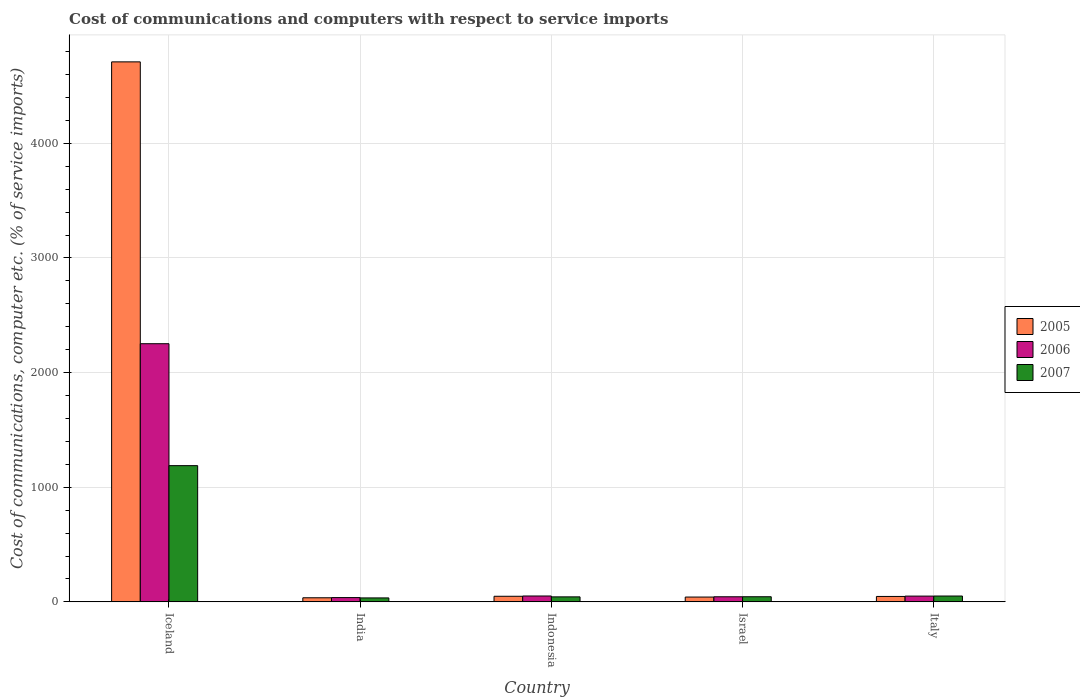How many groups of bars are there?
Your answer should be compact. 5. Are the number of bars on each tick of the X-axis equal?
Ensure brevity in your answer.  Yes. In how many cases, is the number of bars for a given country not equal to the number of legend labels?
Your answer should be compact. 0. What is the cost of communications and computers in 2007 in Iceland?
Offer a terse response. 1188.27. Across all countries, what is the maximum cost of communications and computers in 2005?
Your response must be concise. 4710.44. Across all countries, what is the minimum cost of communications and computers in 2007?
Make the answer very short. 34.57. In which country was the cost of communications and computers in 2007 maximum?
Keep it short and to the point. Iceland. In which country was the cost of communications and computers in 2006 minimum?
Keep it short and to the point. India. What is the total cost of communications and computers in 2006 in the graph?
Offer a very short reply. 2435.6. What is the difference between the cost of communications and computers in 2007 in India and that in Italy?
Give a very brief answer. -16.51. What is the difference between the cost of communications and computers in 2005 in Israel and the cost of communications and computers in 2006 in Indonesia?
Give a very brief answer. -9.27. What is the average cost of communications and computers in 2007 per country?
Ensure brevity in your answer.  272.47. What is the difference between the cost of communications and computers of/in 2006 and cost of communications and computers of/in 2005 in Iceland?
Your answer should be compact. -2458.4. In how many countries, is the cost of communications and computers in 2005 greater than 1200 %?
Offer a very short reply. 1. What is the ratio of the cost of communications and computers in 2005 in Iceland to that in Israel?
Your answer should be compact. 112.13. Is the cost of communications and computers in 2006 in Iceland less than that in Indonesia?
Your answer should be compact. No. Is the difference between the cost of communications and computers in 2006 in India and Italy greater than the difference between the cost of communications and computers in 2005 in India and Italy?
Your answer should be very brief. No. What is the difference between the highest and the second highest cost of communications and computers in 2006?
Provide a succinct answer. -0.94. What is the difference between the highest and the lowest cost of communications and computers in 2006?
Your answer should be very brief. 2214.63. What does the 3rd bar from the left in Italy represents?
Make the answer very short. 2007. What does the 1st bar from the right in Indonesia represents?
Your response must be concise. 2007. How many bars are there?
Keep it short and to the point. 15. How many countries are there in the graph?
Your answer should be compact. 5. What is the difference between two consecutive major ticks on the Y-axis?
Provide a short and direct response. 1000. Does the graph contain any zero values?
Ensure brevity in your answer.  No. Does the graph contain grids?
Ensure brevity in your answer.  Yes. What is the title of the graph?
Your answer should be compact. Cost of communications and computers with respect to service imports. What is the label or title of the Y-axis?
Your answer should be compact. Cost of communications, computer etc. (% of service imports). What is the Cost of communications, computer etc. (% of service imports) of 2005 in Iceland?
Provide a short and direct response. 4710.44. What is the Cost of communications, computer etc. (% of service imports) in 2006 in Iceland?
Your response must be concise. 2252.04. What is the Cost of communications, computer etc. (% of service imports) of 2007 in Iceland?
Keep it short and to the point. 1188.27. What is the Cost of communications, computer etc. (% of service imports) of 2005 in India?
Make the answer very short. 35.82. What is the Cost of communications, computer etc. (% of service imports) in 2006 in India?
Provide a short and direct response. 37.41. What is the Cost of communications, computer etc. (% of service imports) of 2007 in India?
Make the answer very short. 34.57. What is the Cost of communications, computer etc. (% of service imports) of 2005 in Indonesia?
Your answer should be compact. 48.8. What is the Cost of communications, computer etc. (% of service imports) in 2006 in Indonesia?
Your response must be concise. 51.27. What is the Cost of communications, computer etc. (% of service imports) in 2007 in Indonesia?
Offer a terse response. 43.67. What is the Cost of communications, computer etc. (% of service imports) of 2005 in Israel?
Provide a succinct answer. 42.01. What is the Cost of communications, computer etc. (% of service imports) of 2006 in Israel?
Your answer should be compact. 44.54. What is the Cost of communications, computer etc. (% of service imports) in 2007 in Israel?
Your answer should be very brief. 44.77. What is the Cost of communications, computer etc. (% of service imports) of 2005 in Italy?
Give a very brief answer. 47.3. What is the Cost of communications, computer etc. (% of service imports) in 2006 in Italy?
Provide a short and direct response. 50.34. What is the Cost of communications, computer etc. (% of service imports) in 2007 in Italy?
Ensure brevity in your answer.  51.08. Across all countries, what is the maximum Cost of communications, computer etc. (% of service imports) in 2005?
Keep it short and to the point. 4710.44. Across all countries, what is the maximum Cost of communications, computer etc. (% of service imports) of 2006?
Offer a terse response. 2252.04. Across all countries, what is the maximum Cost of communications, computer etc. (% of service imports) in 2007?
Ensure brevity in your answer.  1188.27. Across all countries, what is the minimum Cost of communications, computer etc. (% of service imports) of 2005?
Offer a terse response. 35.82. Across all countries, what is the minimum Cost of communications, computer etc. (% of service imports) in 2006?
Make the answer very short. 37.41. Across all countries, what is the minimum Cost of communications, computer etc. (% of service imports) in 2007?
Offer a very short reply. 34.57. What is the total Cost of communications, computer etc. (% of service imports) in 2005 in the graph?
Give a very brief answer. 4884.37. What is the total Cost of communications, computer etc. (% of service imports) of 2006 in the graph?
Give a very brief answer. 2435.6. What is the total Cost of communications, computer etc. (% of service imports) in 2007 in the graph?
Offer a very short reply. 1362.37. What is the difference between the Cost of communications, computer etc. (% of service imports) of 2005 in Iceland and that in India?
Offer a very short reply. 4674.62. What is the difference between the Cost of communications, computer etc. (% of service imports) of 2006 in Iceland and that in India?
Make the answer very short. 2214.63. What is the difference between the Cost of communications, computer etc. (% of service imports) of 2007 in Iceland and that in India?
Provide a succinct answer. 1153.69. What is the difference between the Cost of communications, computer etc. (% of service imports) in 2005 in Iceland and that in Indonesia?
Make the answer very short. 4661.64. What is the difference between the Cost of communications, computer etc. (% of service imports) of 2006 in Iceland and that in Indonesia?
Provide a short and direct response. 2200.76. What is the difference between the Cost of communications, computer etc. (% of service imports) of 2007 in Iceland and that in Indonesia?
Ensure brevity in your answer.  1144.6. What is the difference between the Cost of communications, computer etc. (% of service imports) of 2005 in Iceland and that in Israel?
Provide a short and direct response. 4668.43. What is the difference between the Cost of communications, computer etc. (% of service imports) in 2006 in Iceland and that in Israel?
Keep it short and to the point. 2207.5. What is the difference between the Cost of communications, computer etc. (% of service imports) in 2007 in Iceland and that in Israel?
Offer a terse response. 1143.5. What is the difference between the Cost of communications, computer etc. (% of service imports) in 2005 in Iceland and that in Italy?
Make the answer very short. 4663.14. What is the difference between the Cost of communications, computer etc. (% of service imports) of 2006 in Iceland and that in Italy?
Your answer should be very brief. 2201.7. What is the difference between the Cost of communications, computer etc. (% of service imports) of 2007 in Iceland and that in Italy?
Provide a succinct answer. 1137.18. What is the difference between the Cost of communications, computer etc. (% of service imports) in 2005 in India and that in Indonesia?
Provide a short and direct response. -12.98. What is the difference between the Cost of communications, computer etc. (% of service imports) in 2006 in India and that in Indonesia?
Your answer should be very brief. -13.87. What is the difference between the Cost of communications, computer etc. (% of service imports) of 2007 in India and that in Indonesia?
Offer a terse response. -9.1. What is the difference between the Cost of communications, computer etc. (% of service imports) of 2005 in India and that in Israel?
Offer a very short reply. -6.19. What is the difference between the Cost of communications, computer etc. (% of service imports) of 2006 in India and that in Israel?
Provide a short and direct response. -7.13. What is the difference between the Cost of communications, computer etc. (% of service imports) in 2007 in India and that in Israel?
Your answer should be very brief. -10.19. What is the difference between the Cost of communications, computer etc. (% of service imports) in 2005 in India and that in Italy?
Keep it short and to the point. -11.48. What is the difference between the Cost of communications, computer etc. (% of service imports) of 2006 in India and that in Italy?
Offer a terse response. -12.93. What is the difference between the Cost of communications, computer etc. (% of service imports) of 2007 in India and that in Italy?
Make the answer very short. -16.51. What is the difference between the Cost of communications, computer etc. (% of service imports) of 2005 in Indonesia and that in Israel?
Give a very brief answer. 6.79. What is the difference between the Cost of communications, computer etc. (% of service imports) of 2006 in Indonesia and that in Israel?
Make the answer very short. 6.74. What is the difference between the Cost of communications, computer etc. (% of service imports) in 2007 in Indonesia and that in Israel?
Ensure brevity in your answer.  -1.1. What is the difference between the Cost of communications, computer etc. (% of service imports) in 2005 in Indonesia and that in Italy?
Make the answer very short. 1.5. What is the difference between the Cost of communications, computer etc. (% of service imports) in 2006 in Indonesia and that in Italy?
Make the answer very short. 0.94. What is the difference between the Cost of communications, computer etc. (% of service imports) in 2007 in Indonesia and that in Italy?
Your response must be concise. -7.41. What is the difference between the Cost of communications, computer etc. (% of service imports) in 2005 in Israel and that in Italy?
Keep it short and to the point. -5.29. What is the difference between the Cost of communications, computer etc. (% of service imports) of 2006 in Israel and that in Italy?
Your response must be concise. -5.8. What is the difference between the Cost of communications, computer etc. (% of service imports) of 2007 in Israel and that in Italy?
Your response must be concise. -6.32. What is the difference between the Cost of communications, computer etc. (% of service imports) in 2005 in Iceland and the Cost of communications, computer etc. (% of service imports) in 2006 in India?
Provide a short and direct response. 4673.03. What is the difference between the Cost of communications, computer etc. (% of service imports) in 2005 in Iceland and the Cost of communications, computer etc. (% of service imports) in 2007 in India?
Give a very brief answer. 4675.87. What is the difference between the Cost of communications, computer etc. (% of service imports) in 2006 in Iceland and the Cost of communications, computer etc. (% of service imports) in 2007 in India?
Your answer should be compact. 2217.46. What is the difference between the Cost of communications, computer etc. (% of service imports) of 2005 in Iceland and the Cost of communications, computer etc. (% of service imports) of 2006 in Indonesia?
Provide a succinct answer. 4659.17. What is the difference between the Cost of communications, computer etc. (% of service imports) of 2005 in Iceland and the Cost of communications, computer etc. (% of service imports) of 2007 in Indonesia?
Ensure brevity in your answer.  4666.77. What is the difference between the Cost of communications, computer etc. (% of service imports) in 2006 in Iceland and the Cost of communications, computer etc. (% of service imports) in 2007 in Indonesia?
Offer a terse response. 2208.36. What is the difference between the Cost of communications, computer etc. (% of service imports) in 2005 in Iceland and the Cost of communications, computer etc. (% of service imports) in 2006 in Israel?
Make the answer very short. 4665.9. What is the difference between the Cost of communications, computer etc. (% of service imports) in 2005 in Iceland and the Cost of communications, computer etc. (% of service imports) in 2007 in Israel?
Offer a terse response. 4665.67. What is the difference between the Cost of communications, computer etc. (% of service imports) of 2006 in Iceland and the Cost of communications, computer etc. (% of service imports) of 2007 in Israel?
Make the answer very short. 2207.27. What is the difference between the Cost of communications, computer etc. (% of service imports) in 2005 in Iceland and the Cost of communications, computer etc. (% of service imports) in 2006 in Italy?
Ensure brevity in your answer.  4660.1. What is the difference between the Cost of communications, computer etc. (% of service imports) in 2005 in Iceland and the Cost of communications, computer etc. (% of service imports) in 2007 in Italy?
Ensure brevity in your answer.  4659.36. What is the difference between the Cost of communications, computer etc. (% of service imports) of 2006 in Iceland and the Cost of communications, computer etc. (% of service imports) of 2007 in Italy?
Offer a very short reply. 2200.95. What is the difference between the Cost of communications, computer etc. (% of service imports) of 2005 in India and the Cost of communications, computer etc. (% of service imports) of 2006 in Indonesia?
Provide a succinct answer. -15.46. What is the difference between the Cost of communications, computer etc. (% of service imports) of 2005 in India and the Cost of communications, computer etc. (% of service imports) of 2007 in Indonesia?
Keep it short and to the point. -7.85. What is the difference between the Cost of communications, computer etc. (% of service imports) of 2006 in India and the Cost of communications, computer etc. (% of service imports) of 2007 in Indonesia?
Offer a very short reply. -6.26. What is the difference between the Cost of communications, computer etc. (% of service imports) in 2005 in India and the Cost of communications, computer etc. (% of service imports) in 2006 in Israel?
Offer a terse response. -8.72. What is the difference between the Cost of communications, computer etc. (% of service imports) in 2005 in India and the Cost of communications, computer etc. (% of service imports) in 2007 in Israel?
Provide a short and direct response. -8.95. What is the difference between the Cost of communications, computer etc. (% of service imports) of 2006 in India and the Cost of communications, computer etc. (% of service imports) of 2007 in Israel?
Your answer should be compact. -7.36. What is the difference between the Cost of communications, computer etc. (% of service imports) of 2005 in India and the Cost of communications, computer etc. (% of service imports) of 2006 in Italy?
Keep it short and to the point. -14.52. What is the difference between the Cost of communications, computer etc. (% of service imports) in 2005 in India and the Cost of communications, computer etc. (% of service imports) in 2007 in Italy?
Ensure brevity in your answer.  -15.27. What is the difference between the Cost of communications, computer etc. (% of service imports) in 2006 in India and the Cost of communications, computer etc. (% of service imports) in 2007 in Italy?
Provide a short and direct response. -13.68. What is the difference between the Cost of communications, computer etc. (% of service imports) of 2005 in Indonesia and the Cost of communications, computer etc. (% of service imports) of 2006 in Israel?
Keep it short and to the point. 4.26. What is the difference between the Cost of communications, computer etc. (% of service imports) in 2005 in Indonesia and the Cost of communications, computer etc. (% of service imports) in 2007 in Israel?
Offer a very short reply. 4.03. What is the difference between the Cost of communications, computer etc. (% of service imports) of 2006 in Indonesia and the Cost of communications, computer etc. (% of service imports) of 2007 in Israel?
Your answer should be compact. 6.51. What is the difference between the Cost of communications, computer etc. (% of service imports) in 2005 in Indonesia and the Cost of communications, computer etc. (% of service imports) in 2006 in Italy?
Keep it short and to the point. -1.54. What is the difference between the Cost of communications, computer etc. (% of service imports) of 2005 in Indonesia and the Cost of communications, computer etc. (% of service imports) of 2007 in Italy?
Ensure brevity in your answer.  -2.28. What is the difference between the Cost of communications, computer etc. (% of service imports) of 2006 in Indonesia and the Cost of communications, computer etc. (% of service imports) of 2007 in Italy?
Your response must be concise. 0.19. What is the difference between the Cost of communications, computer etc. (% of service imports) in 2005 in Israel and the Cost of communications, computer etc. (% of service imports) in 2006 in Italy?
Your answer should be very brief. -8.33. What is the difference between the Cost of communications, computer etc. (% of service imports) in 2005 in Israel and the Cost of communications, computer etc. (% of service imports) in 2007 in Italy?
Your answer should be compact. -9.08. What is the difference between the Cost of communications, computer etc. (% of service imports) in 2006 in Israel and the Cost of communications, computer etc. (% of service imports) in 2007 in Italy?
Offer a very short reply. -6.55. What is the average Cost of communications, computer etc. (% of service imports) of 2005 per country?
Ensure brevity in your answer.  976.87. What is the average Cost of communications, computer etc. (% of service imports) of 2006 per country?
Offer a very short reply. 487.12. What is the average Cost of communications, computer etc. (% of service imports) in 2007 per country?
Offer a very short reply. 272.47. What is the difference between the Cost of communications, computer etc. (% of service imports) of 2005 and Cost of communications, computer etc. (% of service imports) of 2006 in Iceland?
Provide a short and direct response. 2458.4. What is the difference between the Cost of communications, computer etc. (% of service imports) of 2005 and Cost of communications, computer etc. (% of service imports) of 2007 in Iceland?
Offer a very short reply. 3522.17. What is the difference between the Cost of communications, computer etc. (% of service imports) in 2006 and Cost of communications, computer etc. (% of service imports) in 2007 in Iceland?
Your answer should be compact. 1063.77. What is the difference between the Cost of communications, computer etc. (% of service imports) of 2005 and Cost of communications, computer etc. (% of service imports) of 2006 in India?
Provide a short and direct response. -1.59. What is the difference between the Cost of communications, computer etc. (% of service imports) of 2005 and Cost of communications, computer etc. (% of service imports) of 2007 in India?
Give a very brief answer. 1.24. What is the difference between the Cost of communications, computer etc. (% of service imports) of 2006 and Cost of communications, computer etc. (% of service imports) of 2007 in India?
Provide a succinct answer. 2.83. What is the difference between the Cost of communications, computer etc. (% of service imports) of 2005 and Cost of communications, computer etc. (% of service imports) of 2006 in Indonesia?
Offer a very short reply. -2.47. What is the difference between the Cost of communications, computer etc. (% of service imports) in 2005 and Cost of communications, computer etc. (% of service imports) in 2007 in Indonesia?
Offer a terse response. 5.13. What is the difference between the Cost of communications, computer etc. (% of service imports) of 2006 and Cost of communications, computer etc. (% of service imports) of 2007 in Indonesia?
Ensure brevity in your answer.  7.6. What is the difference between the Cost of communications, computer etc. (% of service imports) of 2005 and Cost of communications, computer etc. (% of service imports) of 2006 in Israel?
Keep it short and to the point. -2.53. What is the difference between the Cost of communications, computer etc. (% of service imports) of 2005 and Cost of communications, computer etc. (% of service imports) of 2007 in Israel?
Give a very brief answer. -2.76. What is the difference between the Cost of communications, computer etc. (% of service imports) in 2006 and Cost of communications, computer etc. (% of service imports) in 2007 in Israel?
Keep it short and to the point. -0.23. What is the difference between the Cost of communications, computer etc. (% of service imports) of 2005 and Cost of communications, computer etc. (% of service imports) of 2006 in Italy?
Give a very brief answer. -3.04. What is the difference between the Cost of communications, computer etc. (% of service imports) of 2005 and Cost of communications, computer etc. (% of service imports) of 2007 in Italy?
Make the answer very short. -3.78. What is the difference between the Cost of communications, computer etc. (% of service imports) of 2006 and Cost of communications, computer etc. (% of service imports) of 2007 in Italy?
Your response must be concise. -0.75. What is the ratio of the Cost of communications, computer etc. (% of service imports) in 2005 in Iceland to that in India?
Provide a short and direct response. 131.51. What is the ratio of the Cost of communications, computer etc. (% of service imports) in 2006 in Iceland to that in India?
Your answer should be very brief. 60.2. What is the ratio of the Cost of communications, computer etc. (% of service imports) of 2007 in Iceland to that in India?
Give a very brief answer. 34.37. What is the ratio of the Cost of communications, computer etc. (% of service imports) in 2005 in Iceland to that in Indonesia?
Offer a very short reply. 96.52. What is the ratio of the Cost of communications, computer etc. (% of service imports) in 2006 in Iceland to that in Indonesia?
Provide a short and direct response. 43.92. What is the ratio of the Cost of communications, computer etc. (% of service imports) of 2007 in Iceland to that in Indonesia?
Your response must be concise. 27.21. What is the ratio of the Cost of communications, computer etc. (% of service imports) of 2005 in Iceland to that in Israel?
Make the answer very short. 112.13. What is the ratio of the Cost of communications, computer etc. (% of service imports) in 2006 in Iceland to that in Israel?
Keep it short and to the point. 50.56. What is the ratio of the Cost of communications, computer etc. (% of service imports) in 2007 in Iceland to that in Israel?
Provide a short and direct response. 26.54. What is the ratio of the Cost of communications, computer etc. (% of service imports) in 2005 in Iceland to that in Italy?
Give a very brief answer. 99.58. What is the ratio of the Cost of communications, computer etc. (% of service imports) in 2006 in Iceland to that in Italy?
Give a very brief answer. 44.74. What is the ratio of the Cost of communications, computer etc. (% of service imports) in 2007 in Iceland to that in Italy?
Keep it short and to the point. 23.26. What is the ratio of the Cost of communications, computer etc. (% of service imports) of 2005 in India to that in Indonesia?
Give a very brief answer. 0.73. What is the ratio of the Cost of communications, computer etc. (% of service imports) of 2006 in India to that in Indonesia?
Your response must be concise. 0.73. What is the ratio of the Cost of communications, computer etc. (% of service imports) in 2007 in India to that in Indonesia?
Keep it short and to the point. 0.79. What is the ratio of the Cost of communications, computer etc. (% of service imports) of 2005 in India to that in Israel?
Ensure brevity in your answer.  0.85. What is the ratio of the Cost of communications, computer etc. (% of service imports) of 2006 in India to that in Israel?
Offer a terse response. 0.84. What is the ratio of the Cost of communications, computer etc. (% of service imports) in 2007 in India to that in Israel?
Offer a terse response. 0.77. What is the ratio of the Cost of communications, computer etc. (% of service imports) of 2005 in India to that in Italy?
Provide a short and direct response. 0.76. What is the ratio of the Cost of communications, computer etc. (% of service imports) in 2006 in India to that in Italy?
Your response must be concise. 0.74. What is the ratio of the Cost of communications, computer etc. (% of service imports) in 2007 in India to that in Italy?
Give a very brief answer. 0.68. What is the ratio of the Cost of communications, computer etc. (% of service imports) of 2005 in Indonesia to that in Israel?
Ensure brevity in your answer.  1.16. What is the ratio of the Cost of communications, computer etc. (% of service imports) in 2006 in Indonesia to that in Israel?
Provide a short and direct response. 1.15. What is the ratio of the Cost of communications, computer etc. (% of service imports) of 2007 in Indonesia to that in Israel?
Your answer should be very brief. 0.98. What is the ratio of the Cost of communications, computer etc. (% of service imports) of 2005 in Indonesia to that in Italy?
Your response must be concise. 1.03. What is the ratio of the Cost of communications, computer etc. (% of service imports) of 2006 in Indonesia to that in Italy?
Keep it short and to the point. 1.02. What is the ratio of the Cost of communications, computer etc. (% of service imports) of 2007 in Indonesia to that in Italy?
Your answer should be compact. 0.85. What is the ratio of the Cost of communications, computer etc. (% of service imports) of 2005 in Israel to that in Italy?
Make the answer very short. 0.89. What is the ratio of the Cost of communications, computer etc. (% of service imports) of 2006 in Israel to that in Italy?
Ensure brevity in your answer.  0.88. What is the ratio of the Cost of communications, computer etc. (% of service imports) in 2007 in Israel to that in Italy?
Offer a very short reply. 0.88. What is the difference between the highest and the second highest Cost of communications, computer etc. (% of service imports) in 2005?
Provide a short and direct response. 4661.64. What is the difference between the highest and the second highest Cost of communications, computer etc. (% of service imports) in 2006?
Keep it short and to the point. 2200.76. What is the difference between the highest and the second highest Cost of communications, computer etc. (% of service imports) of 2007?
Offer a very short reply. 1137.18. What is the difference between the highest and the lowest Cost of communications, computer etc. (% of service imports) of 2005?
Give a very brief answer. 4674.62. What is the difference between the highest and the lowest Cost of communications, computer etc. (% of service imports) of 2006?
Provide a succinct answer. 2214.63. What is the difference between the highest and the lowest Cost of communications, computer etc. (% of service imports) in 2007?
Offer a very short reply. 1153.69. 